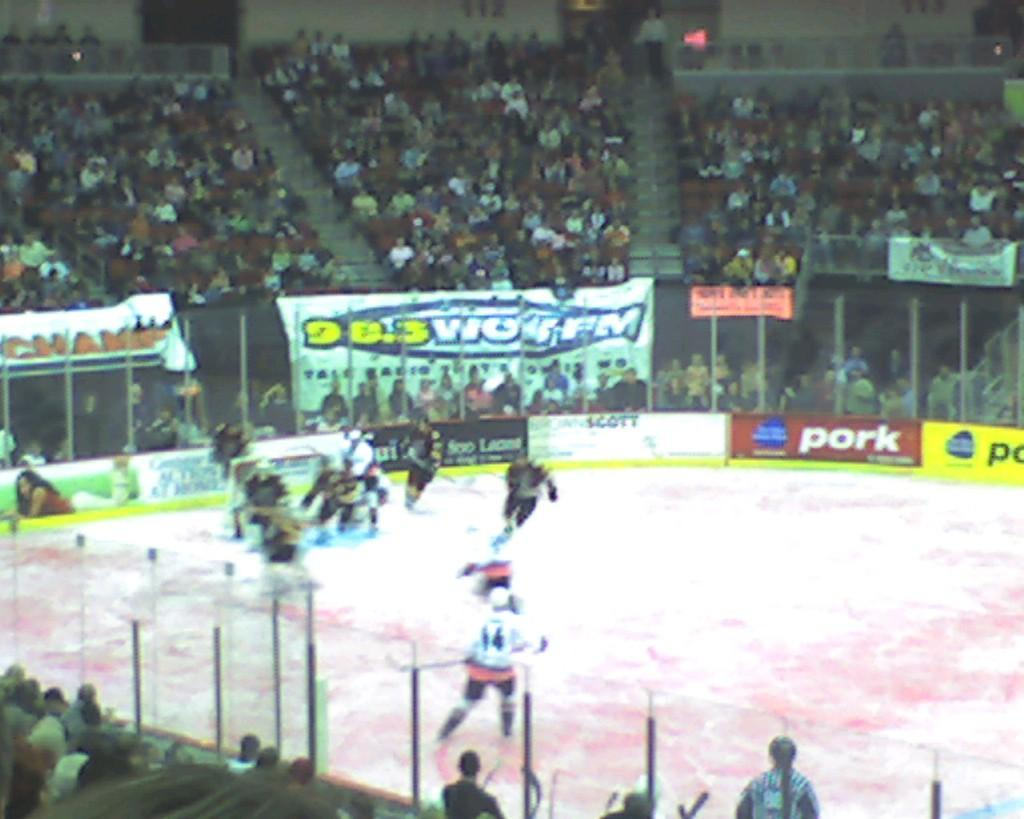<image>
Create a compact narrative representing the image presented. A fairly packed stadium at a hocky game with 98.3 WOR FM as a sponsor. 